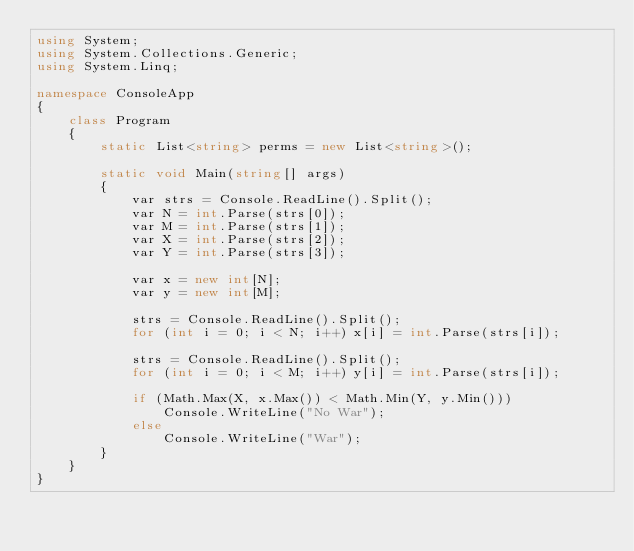<code> <loc_0><loc_0><loc_500><loc_500><_C#_>using System;
using System.Collections.Generic;
using System.Linq;

namespace ConsoleApp
{
    class Program
    {
        static List<string> perms = new List<string>();

        static void Main(string[] args)
        {
            var strs = Console.ReadLine().Split();
            var N = int.Parse(strs[0]);
            var M = int.Parse(strs[1]);
            var X = int.Parse(strs[2]);
            var Y = int.Parse(strs[3]);

            var x = new int[N];
            var y = new int[M];

            strs = Console.ReadLine().Split();
            for (int i = 0; i < N; i++) x[i] = int.Parse(strs[i]);

            strs = Console.ReadLine().Split();
            for (int i = 0; i < M; i++) y[i] = int.Parse(strs[i]);

            if (Math.Max(X, x.Max()) < Math.Min(Y, y.Min()))
                Console.WriteLine("No War");
            else
                Console.WriteLine("War");
        }
    }
}
</code> 